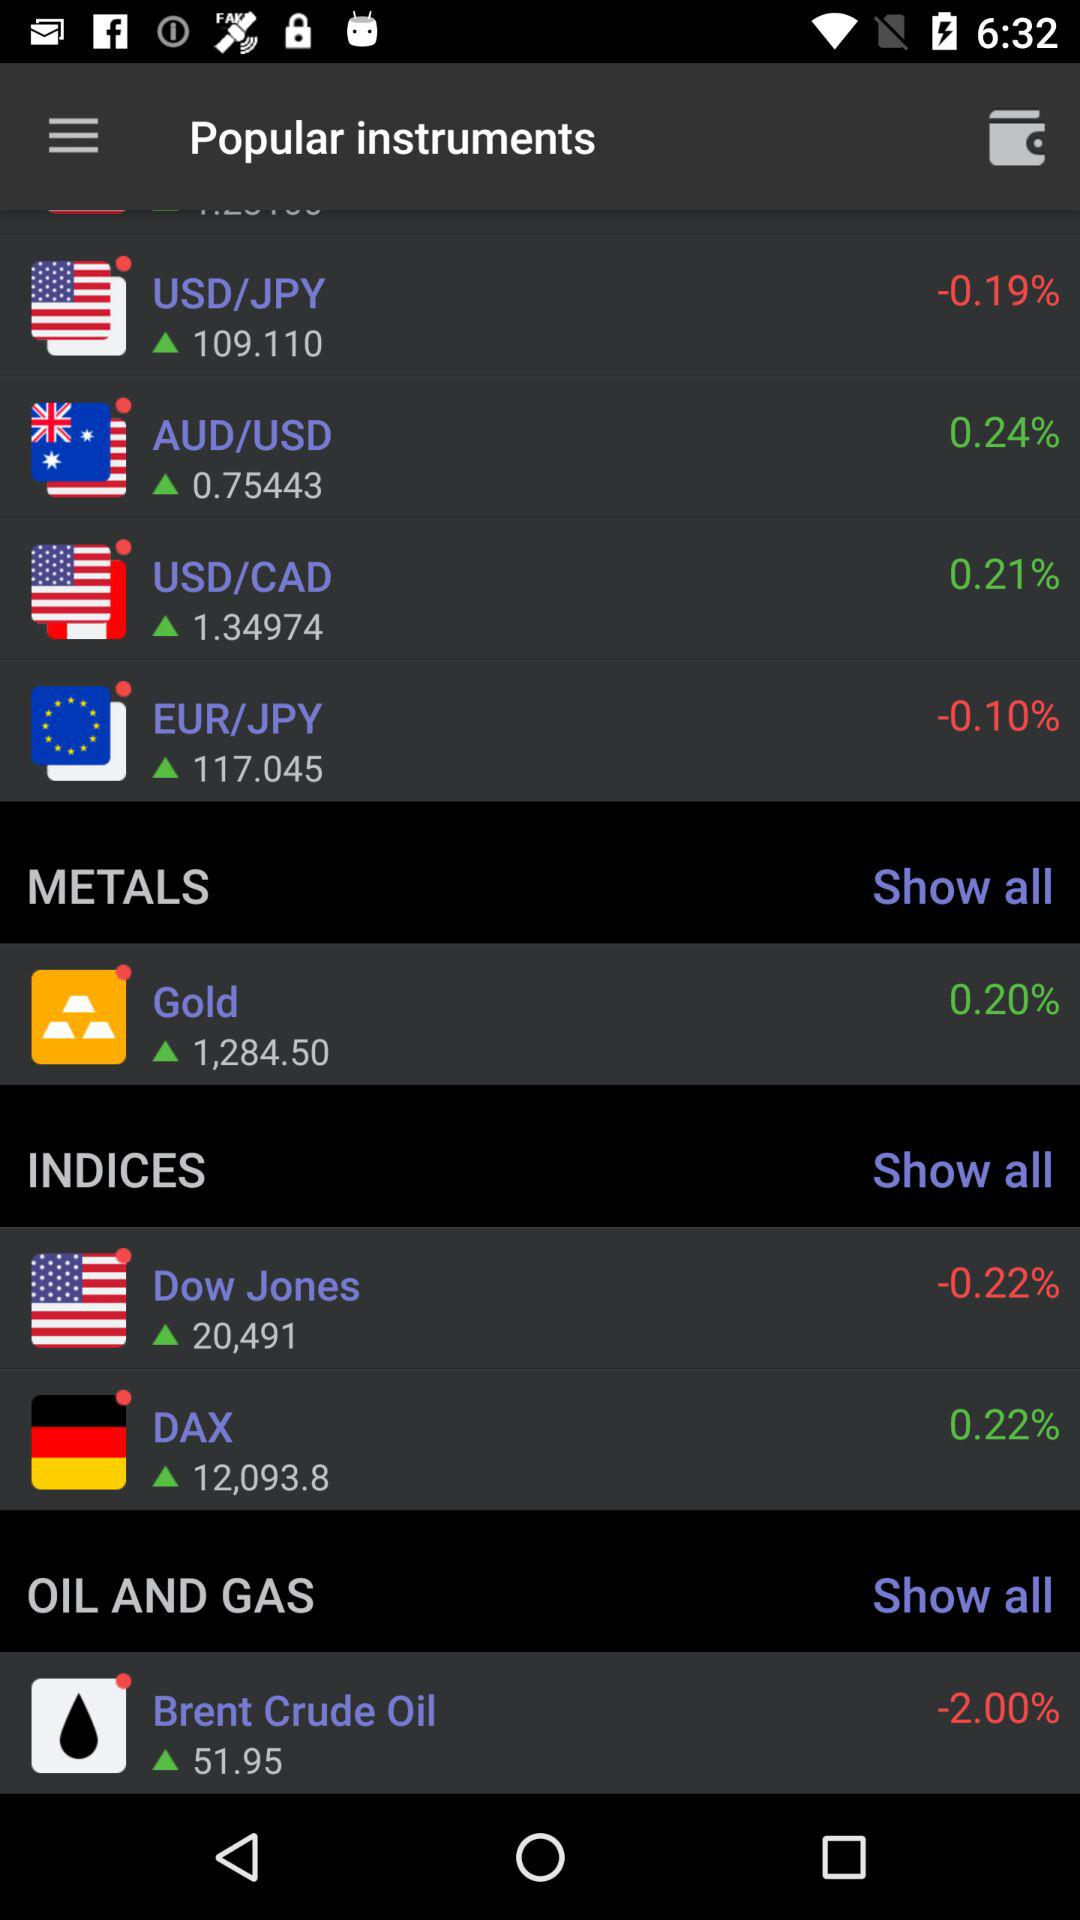Which instrument has the largest change in value?
Answer the question using a single word or phrase. Brent Crude Oil 